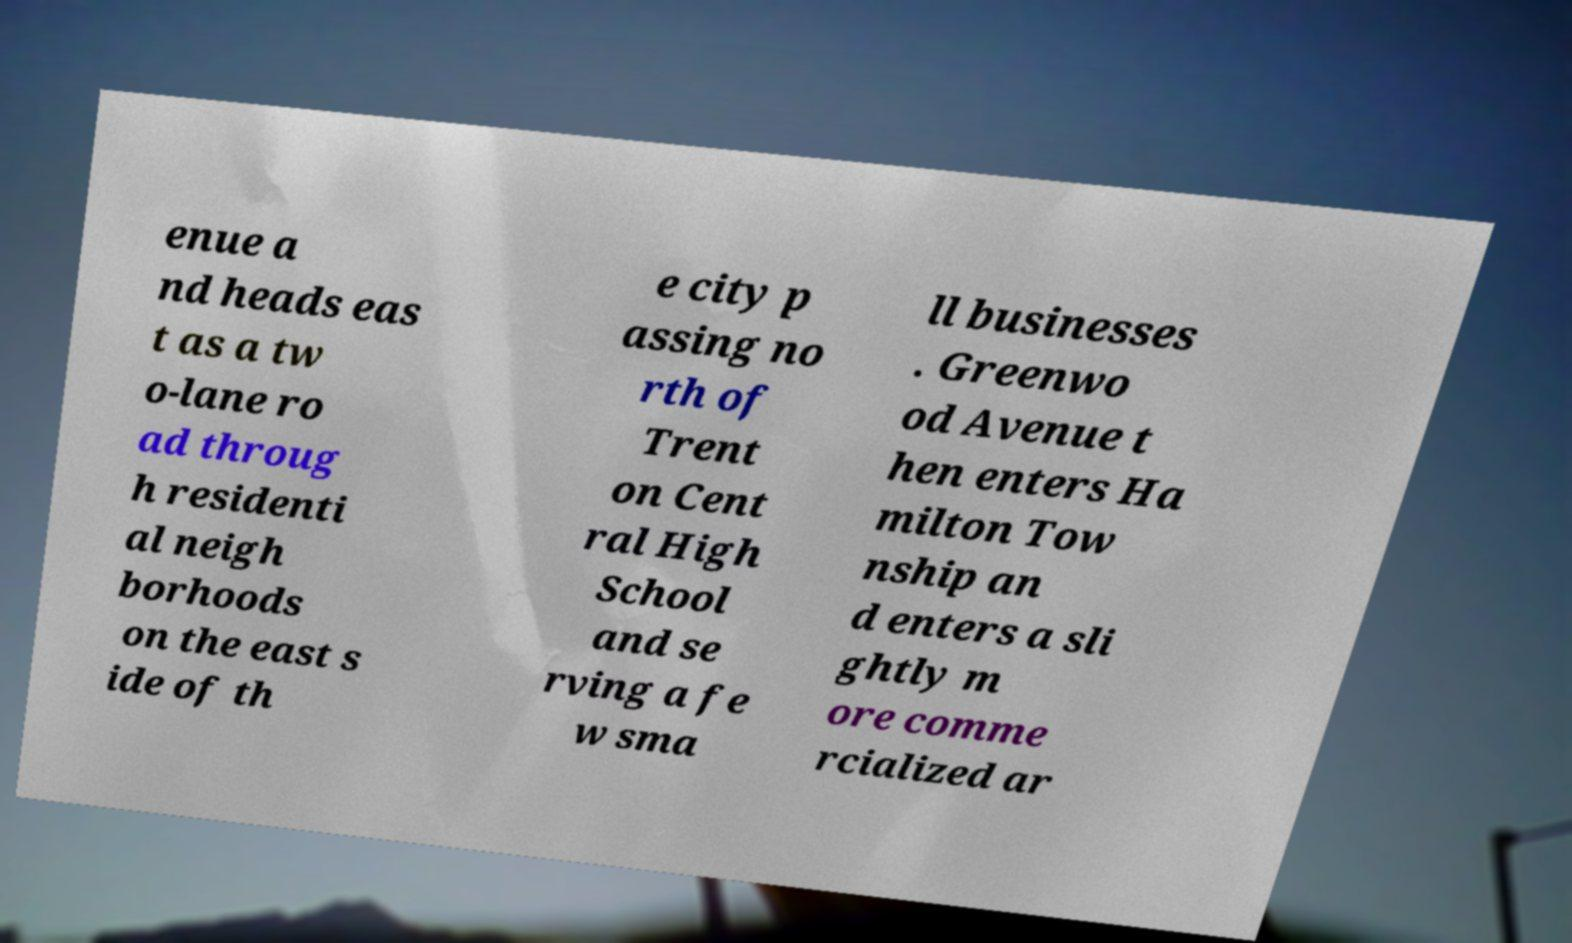Could you assist in decoding the text presented in this image and type it out clearly? enue a nd heads eas t as a tw o-lane ro ad throug h residenti al neigh borhoods on the east s ide of th e city p assing no rth of Trent on Cent ral High School and se rving a fe w sma ll businesses . Greenwo od Avenue t hen enters Ha milton Tow nship an d enters a sli ghtly m ore comme rcialized ar 